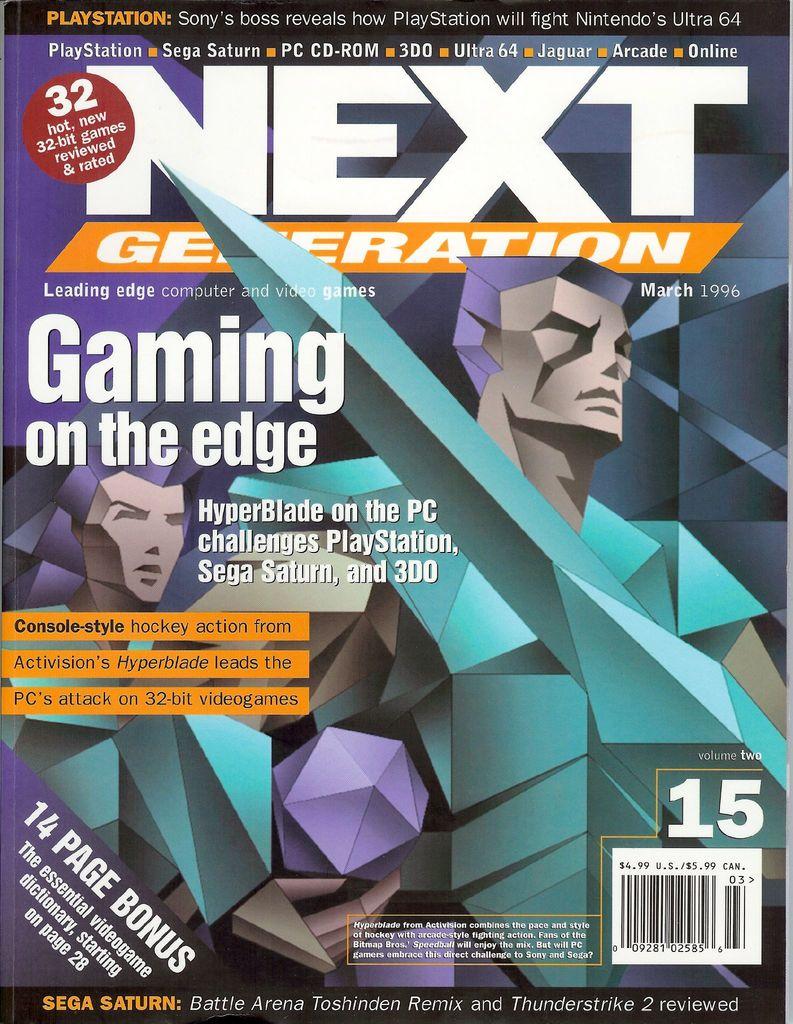What is the name of this magazine?
Your answer should be very brief. Next generation. What issue is the magazine?
Your answer should be compact. 15. 